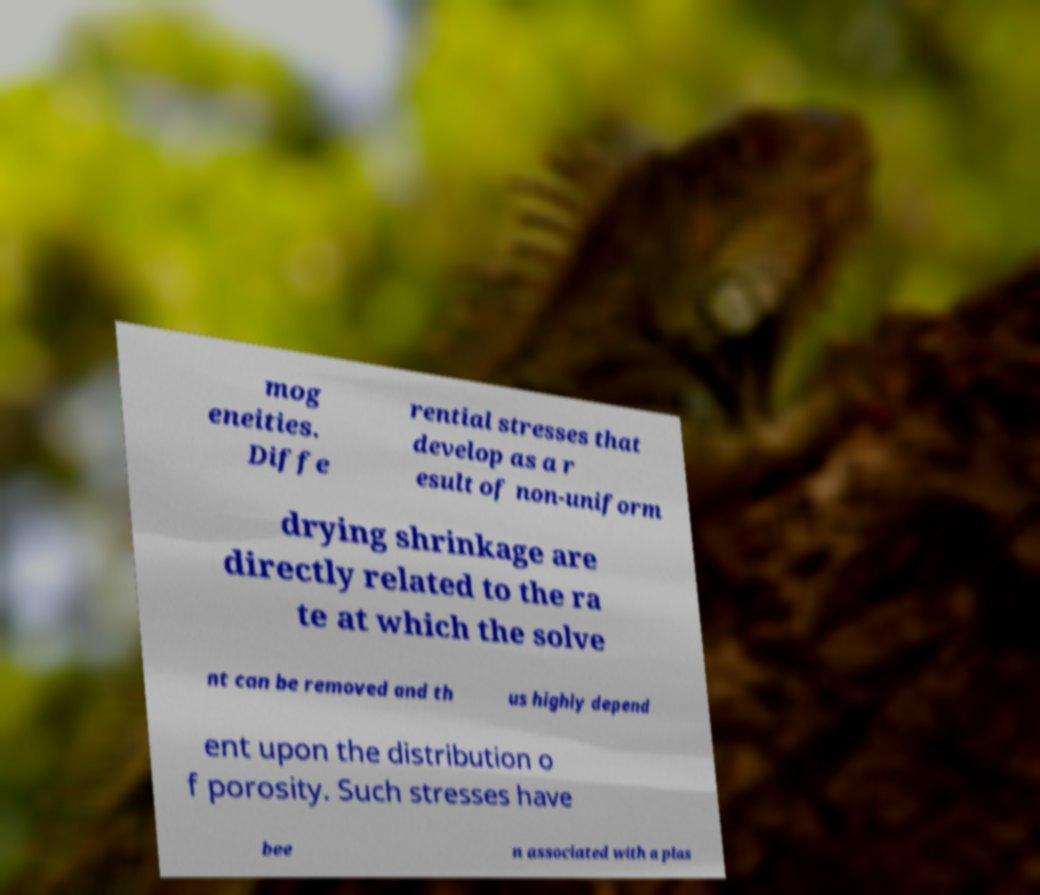Could you extract and type out the text from this image? mog eneities. Diffe rential stresses that develop as a r esult of non-uniform drying shrinkage are directly related to the ra te at which the solve nt can be removed and th us highly depend ent upon the distribution o f porosity. Such stresses have bee n associated with a plas 